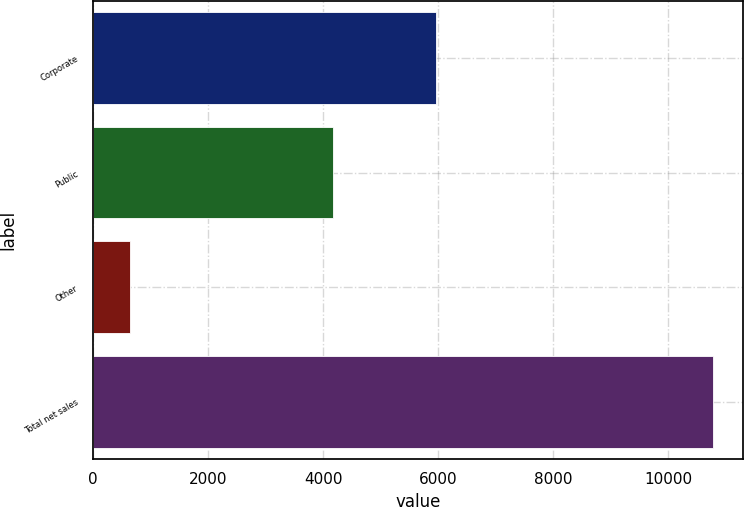Convert chart. <chart><loc_0><loc_0><loc_500><loc_500><bar_chart><fcel>Corporate<fcel>Public<fcel>Other<fcel>Total net sales<nl><fcel>5960.1<fcel>4164.5<fcel>644<fcel>10768.6<nl></chart> 